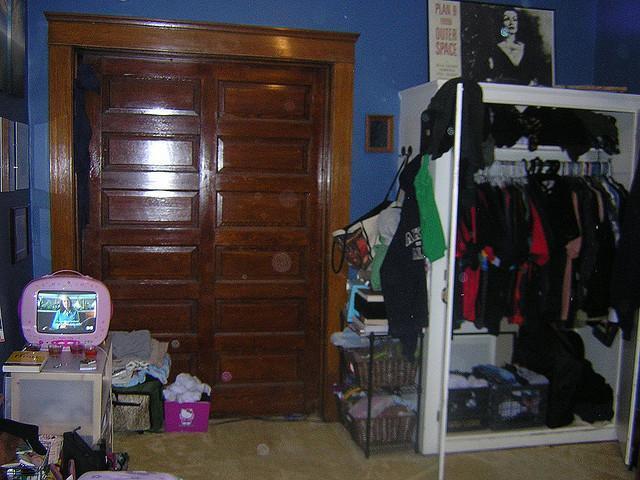How many shoes are on the shelf?
Give a very brief answer. 0. How many teddy bears are there?
Give a very brief answer. 0. 